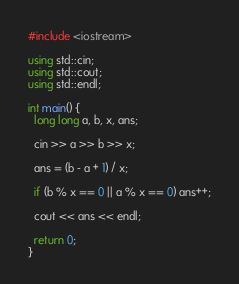<code> <loc_0><loc_0><loc_500><loc_500><_C++_>#include <iostream>

using std::cin;
using std::cout;
using std::endl;

int main() {
  long long a, b, x, ans;

  cin >> a >> b >> x;

  ans = (b - a + 1) / x;

  if (b % x == 0 || a % x == 0) ans++;

  cout << ans << endl;

  return 0;
}
</code> 